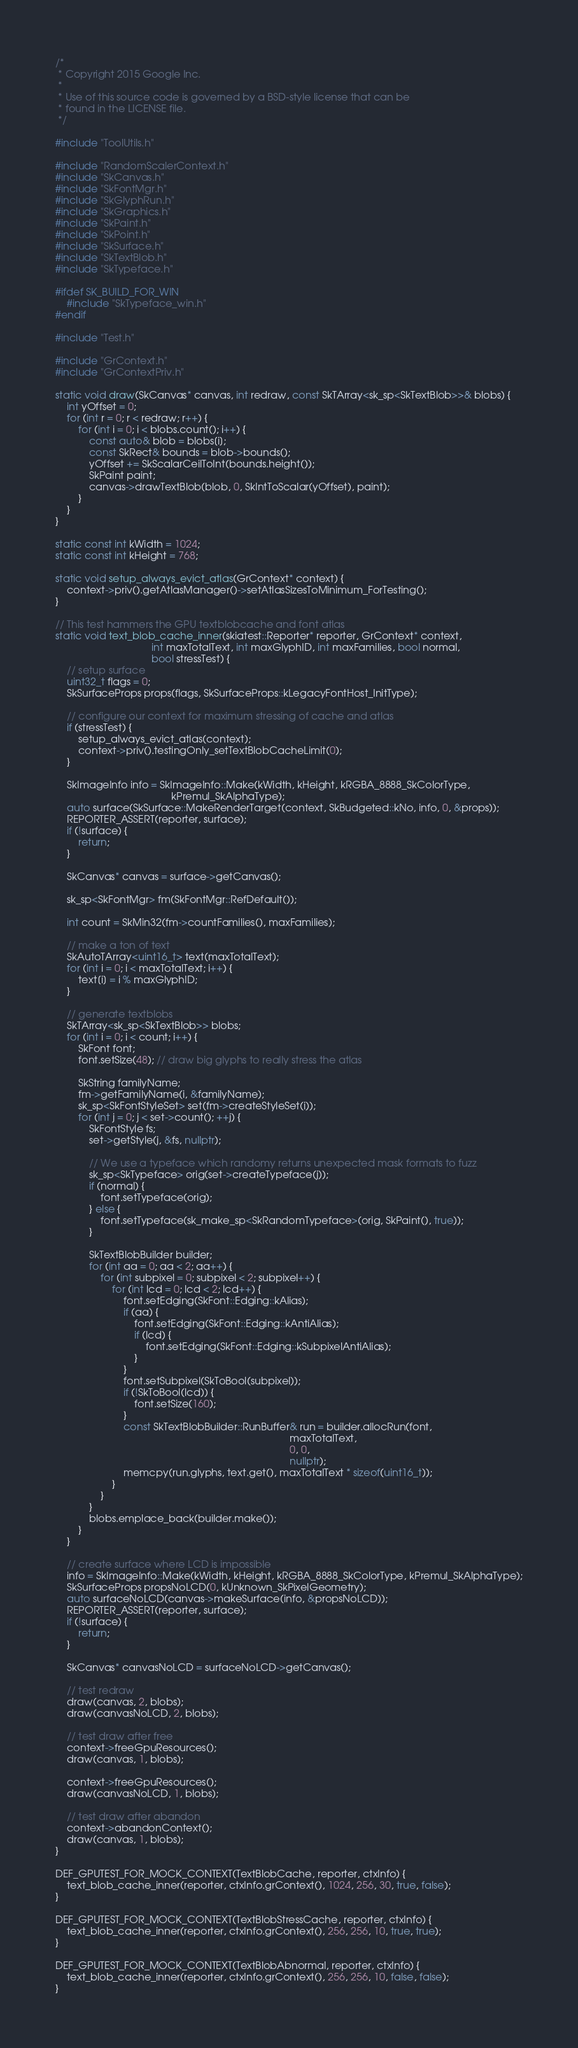Convert code to text. <code><loc_0><loc_0><loc_500><loc_500><_C++_>/*
 * Copyright 2015 Google Inc.
 *
 * Use of this source code is governed by a BSD-style license that can be
 * found in the LICENSE file.
 */

#include "ToolUtils.h"

#include "RandomScalerContext.h"
#include "SkCanvas.h"
#include "SkFontMgr.h"
#include "SkGlyphRun.h"
#include "SkGraphics.h"
#include "SkPaint.h"
#include "SkPoint.h"
#include "SkSurface.h"
#include "SkTextBlob.h"
#include "SkTypeface.h"

#ifdef SK_BUILD_FOR_WIN
    #include "SkTypeface_win.h"
#endif

#include "Test.h"

#include "GrContext.h"
#include "GrContextPriv.h"

static void draw(SkCanvas* canvas, int redraw, const SkTArray<sk_sp<SkTextBlob>>& blobs) {
    int yOffset = 0;
    for (int r = 0; r < redraw; r++) {
        for (int i = 0; i < blobs.count(); i++) {
            const auto& blob = blobs[i];
            const SkRect& bounds = blob->bounds();
            yOffset += SkScalarCeilToInt(bounds.height());
            SkPaint paint;
            canvas->drawTextBlob(blob, 0, SkIntToScalar(yOffset), paint);
        }
    }
}

static const int kWidth = 1024;
static const int kHeight = 768;

static void setup_always_evict_atlas(GrContext* context) {
    context->priv().getAtlasManager()->setAtlasSizesToMinimum_ForTesting();
}

// This test hammers the GPU textblobcache and font atlas
static void text_blob_cache_inner(skiatest::Reporter* reporter, GrContext* context,
                                  int maxTotalText, int maxGlyphID, int maxFamilies, bool normal,
                                  bool stressTest) {
    // setup surface
    uint32_t flags = 0;
    SkSurfaceProps props(flags, SkSurfaceProps::kLegacyFontHost_InitType);

    // configure our context for maximum stressing of cache and atlas
    if (stressTest) {
        setup_always_evict_atlas(context);
        context->priv().testingOnly_setTextBlobCacheLimit(0);
    }

    SkImageInfo info = SkImageInfo::Make(kWidth, kHeight, kRGBA_8888_SkColorType,
                                         kPremul_SkAlphaType);
    auto surface(SkSurface::MakeRenderTarget(context, SkBudgeted::kNo, info, 0, &props));
    REPORTER_ASSERT(reporter, surface);
    if (!surface) {
        return;
    }

    SkCanvas* canvas = surface->getCanvas();

    sk_sp<SkFontMgr> fm(SkFontMgr::RefDefault());

    int count = SkMin32(fm->countFamilies(), maxFamilies);

    // make a ton of text
    SkAutoTArray<uint16_t> text(maxTotalText);
    for (int i = 0; i < maxTotalText; i++) {
        text[i] = i % maxGlyphID;
    }

    // generate textblobs
    SkTArray<sk_sp<SkTextBlob>> blobs;
    for (int i = 0; i < count; i++) {
        SkFont font;
        font.setSize(48); // draw big glyphs to really stress the atlas

        SkString familyName;
        fm->getFamilyName(i, &familyName);
        sk_sp<SkFontStyleSet> set(fm->createStyleSet(i));
        for (int j = 0; j < set->count(); ++j) {
            SkFontStyle fs;
            set->getStyle(j, &fs, nullptr);

            // We use a typeface which randomy returns unexpected mask formats to fuzz
            sk_sp<SkTypeface> orig(set->createTypeface(j));
            if (normal) {
                font.setTypeface(orig);
            } else {
                font.setTypeface(sk_make_sp<SkRandomTypeface>(orig, SkPaint(), true));
            }

            SkTextBlobBuilder builder;
            for (int aa = 0; aa < 2; aa++) {
                for (int subpixel = 0; subpixel < 2; subpixel++) {
                    for (int lcd = 0; lcd < 2; lcd++) {
                        font.setEdging(SkFont::Edging::kAlias);
                        if (aa) {
                            font.setEdging(SkFont::Edging::kAntiAlias);
                            if (lcd) {
                                font.setEdging(SkFont::Edging::kSubpixelAntiAlias);
                            }
                        }
                        font.setSubpixel(SkToBool(subpixel));
                        if (!SkToBool(lcd)) {
                            font.setSize(160);
                        }
                        const SkTextBlobBuilder::RunBuffer& run = builder.allocRun(font,
                                                                                   maxTotalText,
                                                                                   0, 0,
                                                                                   nullptr);
                        memcpy(run.glyphs, text.get(), maxTotalText * sizeof(uint16_t));
                    }
                }
            }
            blobs.emplace_back(builder.make());
        }
    }

    // create surface where LCD is impossible
    info = SkImageInfo::Make(kWidth, kHeight, kRGBA_8888_SkColorType, kPremul_SkAlphaType);
    SkSurfaceProps propsNoLCD(0, kUnknown_SkPixelGeometry);
    auto surfaceNoLCD(canvas->makeSurface(info, &propsNoLCD));
    REPORTER_ASSERT(reporter, surface);
    if (!surface) {
        return;
    }

    SkCanvas* canvasNoLCD = surfaceNoLCD->getCanvas();

    // test redraw
    draw(canvas, 2, blobs);
    draw(canvasNoLCD, 2, blobs);

    // test draw after free
    context->freeGpuResources();
    draw(canvas, 1, blobs);

    context->freeGpuResources();
    draw(canvasNoLCD, 1, blobs);

    // test draw after abandon
    context->abandonContext();
    draw(canvas, 1, blobs);
}

DEF_GPUTEST_FOR_MOCK_CONTEXT(TextBlobCache, reporter, ctxInfo) {
    text_blob_cache_inner(reporter, ctxInfo.grContext(), 1024, 256, 30, true, false);
}

DEF_GPUTEST_FOR_MOCK_CONTEXT(TextBlobStressCache, reporter, ctxInfo) {
    text_blob_cache_inner(reporter, ctxInfo.grContext(), 256, 256, 10, true, true);
}

DEF_GPUTEST_FOR_MOCK_CONTEXT(TextBlobAbnormal, reporter, ctxInfo) {
    text_blob_cache_inner(reporter, ctxInfo.grContext(), 256, 256, 10, false, false);
}
</code> 